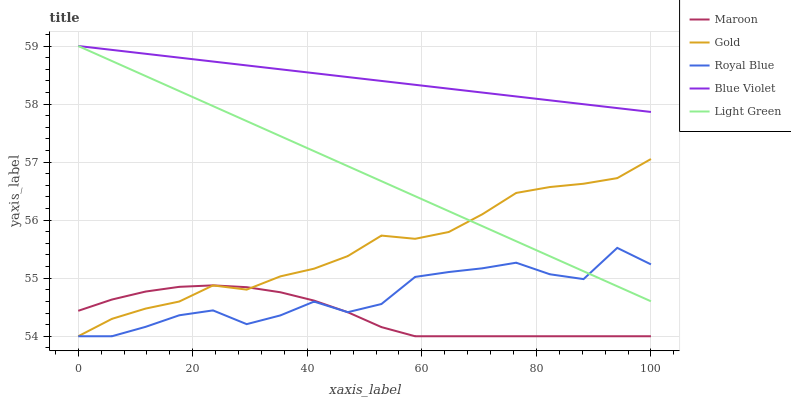Does Maroon have the minimum area under the curve?
Answer yes or no. Yes. Does Blue Violet have the maximum area under the curve?
Answer yes or no. Yes. Does Royal Blue have the minimum area under the curve?
Answer yes or no. No. Does Royal Blue have the maximum area under the curve?
Answer yes or no. No. Is Light Green the smoothest?
Answer yes or no. Yes. Is Royal Blue the roughest?
Answer yes or no. Yes. Is Royal Blue the smoothest?
Answer yes or no. No. Is Light Green the roughest?
Answer yes or no. No. Does Royal Blue have the lowest value?
Answer yes or no. Yes. Does Light Green have the lowest value?
Answer yes or no. No. Does Light Green have the highest value?
Answer yes or no. Yes. Does Royal Blue have the highest value?
Answer yes or no. No. Is Royal Blue less than Blue Violet?
Answer yes or no. Yes. Is Blue Violet greater than Gold?
Answer yes or no. Yes. Does Light Green intersect Royal Blue?
Answer yes or no. Yes. Is Light Green less than Royal Blue?
Answer yes or no. No. Is Light Green greater than Royal Blue?
Answer yes or no. No. Does Royal Blue intersect Blue Violet?
Answer yes or no. No. 